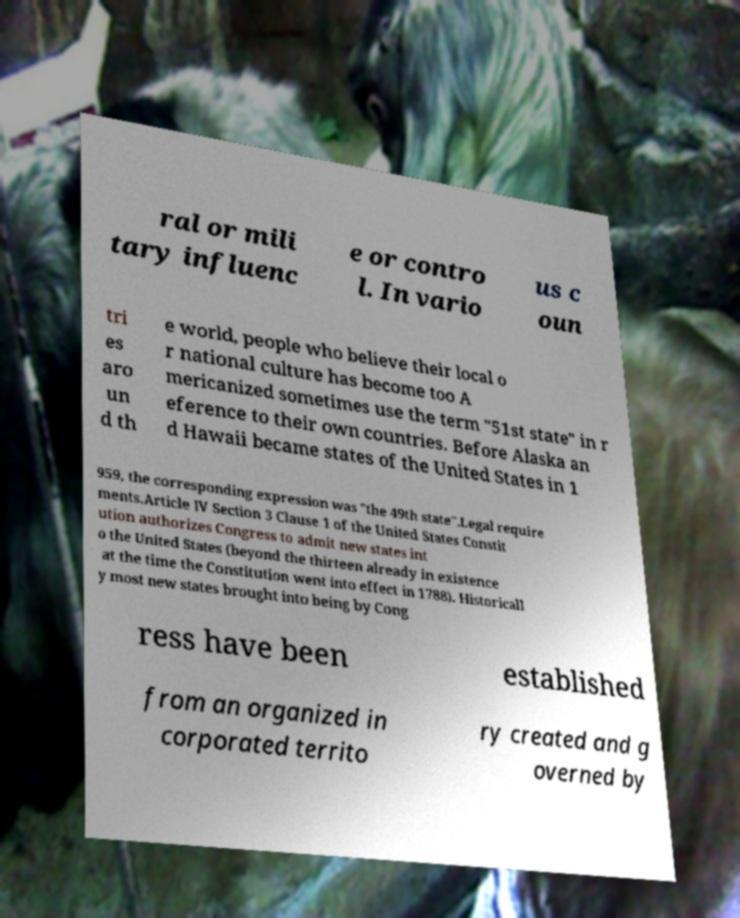There's text embedded in this image that I need extracted. Can you transcribe it verbatim? ral or mili tary influenc e or contro l. In vario us c oun tri es aro un d th e world, people who believe their local o r national culture has become too A mericanized sometimes use the term "51st state" in r eference to their own countries. Before Alaska an d Hawaii became states of the United States in 1 959, the corresponding expression was "the 49th state".Legal require ments.Article IV Section 3 Clause 1 of the United States Constit ution authorizes Congress to admit new states int o the United States (beyond the thirteen already in existence at the time the Constitution went into effect in 1788). Historicall y most new states brought into being by Cong ress have been established from an organized in corporated territo ry created and g overned by 